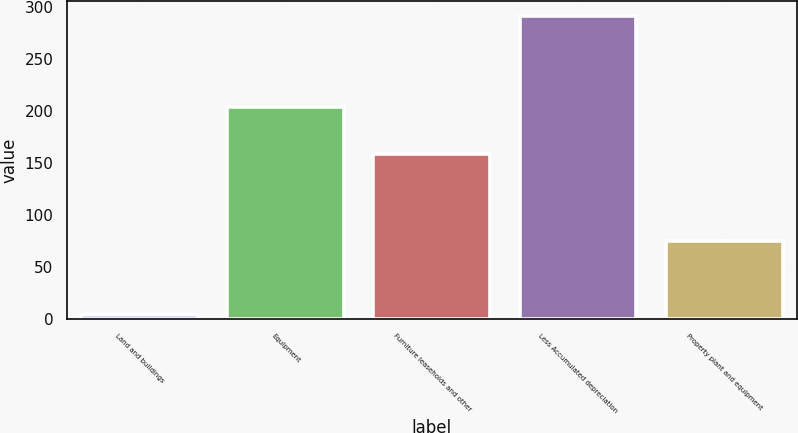Convert chart to OTSL. <chart><loc_0><loc_0><loc_500><loc_500><bar_chart><fcel>Land and buildings<fcel>Equipment<fcel>Furniture leaseholds and other<fcel>Less Accumulated depreciation<fcel>Property plant and equipment<nl><fcel>4.2<fcel>203.2<fcel>158.7<fcel>290.7<fcel>75.4<nl></chart> 